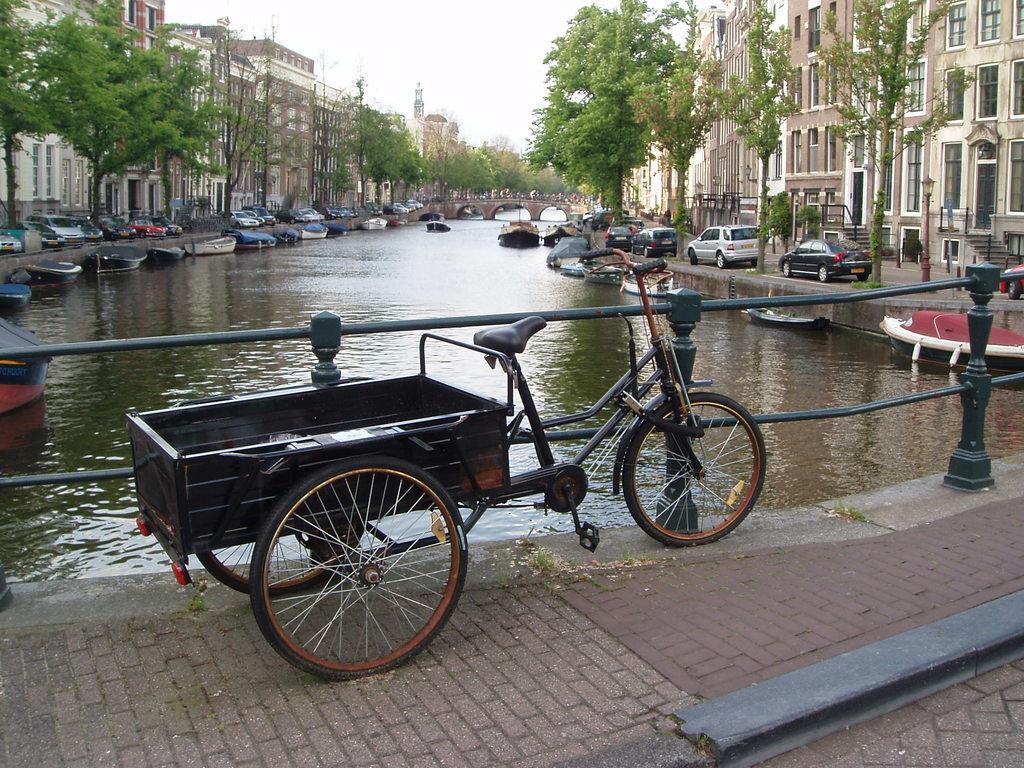Could you give a brief overview of what you see in this image? In this image we can see a bicycle cart. Behind the bicycle cart fencing is there and lake is present. So many boats are on the surface of water. To the both sides of the image trees and buildings are there. In front of the buildings cars are parked. Bottom of the image pavement is present. 